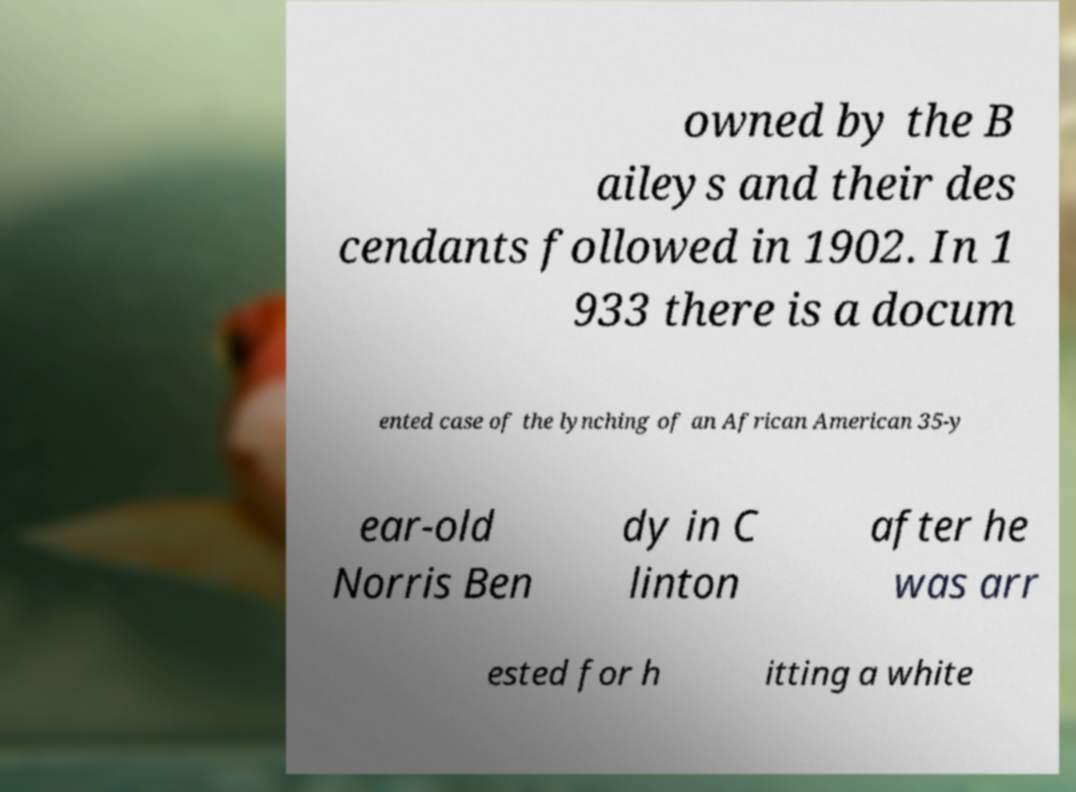What messages or text are displayed in this image? I need them in a readable, typed format. owned by the B aileys and their des cendants followed in 1902. In 1 933 there is a docum ented case of the lynching of an African American 35-y ear-old Norris Ben dy in C linton after he was arr ested for h itting a white 